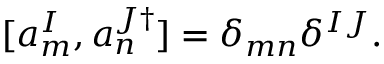Convert formula to latex. <formula><loc_0><loc_0><loc_500><loc_500>[ a _ { m } ^ { I } , a _ { n } ^ { J \dagger } ] = \delta _ { m n } \delta ^ { I J } .</formula> 